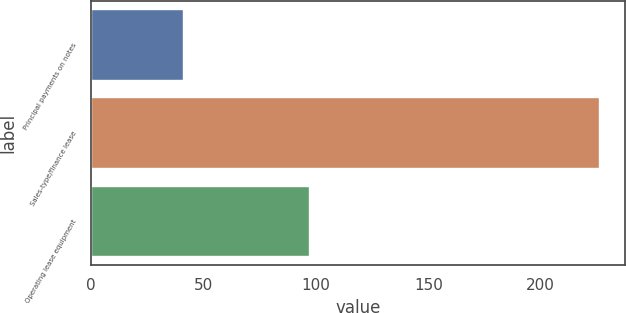<chart> <loc_0><loc_0><loc_500><loc_500><bar_chart><fcel>Principal payments on notes<fcel>Sales-type/finance lease<fcel>Operating lease equipment<nl><fcel>41<fcel>226<fcel>97<nl></chart> 